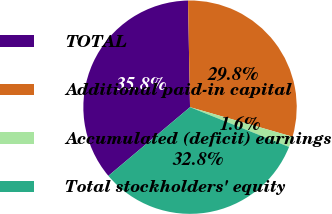Convert chart. <chart><loc_0><loc_0><loc_500><loc_500><pie_chart><fcel>TOTAL<fcel>Additional paid-in capital<fcel>Accumulated (deficit) earnings<fcel>Total stockholders' equity<nl><fcel>35.83%<fcel>29.77%<fcel>1.61%<fcel>32.8%<nl></chart> 